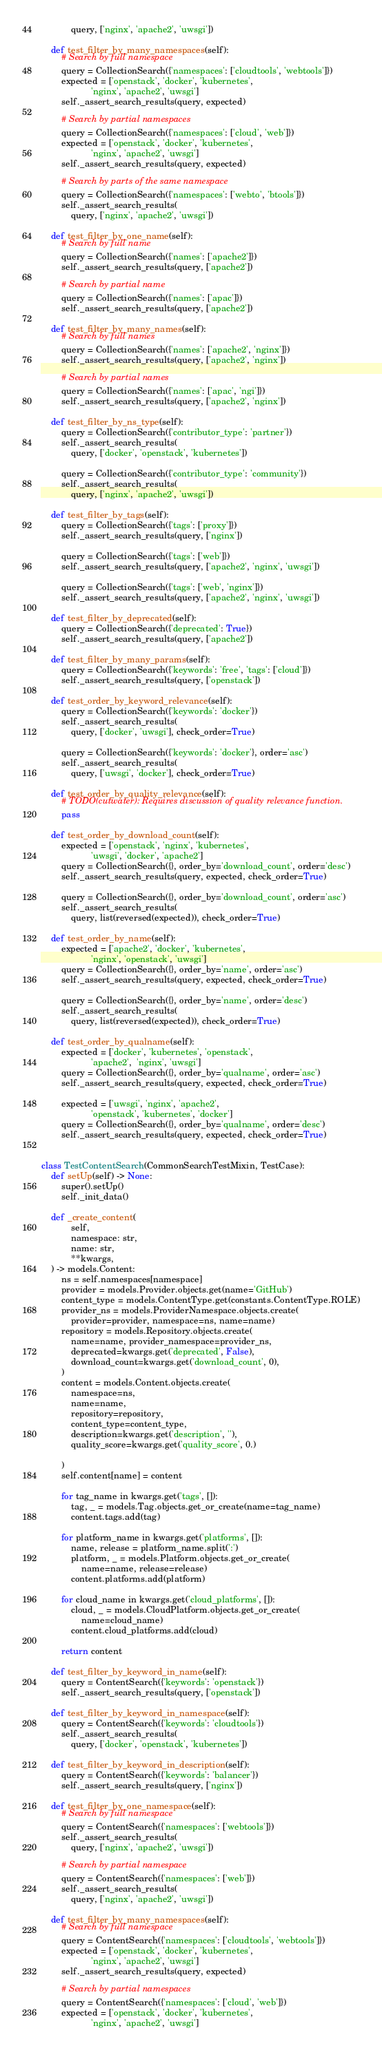Convert code to text. <code><loc_0><loc_0><loc_500><loc_500><_Python_>            query, ['nginx', 'apache2', 'uwsgi'])

    def test_filter_by_many_namespaces(self):
        # Search by full namespace
        query = CollectionSearch({'namespaces': ['cloudtools', 'webtools']})
        expected = ['openstack', 'docker', 'kubernetes',
                    'nginx', 'apache2', 'uwsgi']
        self._assert_search_results(query, expected)

        # Search by partial namespaces
        query = CollectionSearch({'namespaces': ['cloud', 'web']})
        expected = ['openstack', 'docker', 'kubernetes',
                    'nginx', 'apache2', 'uwsgi']
        self._assert_search_results(query, expected)

        # Search by parts of the same namespace
        query = CollectionSearch({'namespaces': ['webto', 'btools']})
        self._assert_search_results(
            query, ['nginx', 'apache2', 'uwsgi'])

    def test_filter_by_one_name(self):
        # Search by full name
        query = CollectionSearch({'names': ['apache2']})
        self._assert_search_results(query, ['apache2'])

        # Search by partial name
        query = CollectionSearch({'names': ['apac']})
        self._assert_search_results(query, ['apache2'])

    def test_filter_by_many_names(self):
        # Search by full names
        query = CollectionSearch({'names': ['apache2', 'nginx']})
        self._assert_search_results(query, ['apache2', 'nginx'])

        # Search by partial names
        query = CollectionSearch({'names': ['apac', 'ngi']})
        self._assert_search_results(query, ['apache2', 'nginx'])

    def test_filter_by_ns_type(self):
        query = CollectionSearch({'contributor_type': 'partner'})
        self._assert_search_results(
            query, ['docker', 'openstack', 'kubernetes'])

        query = CollectionSearch({'contributor_type': 'community'})
        self._assert_search_results(
            query, ['nginx', 'apache2', 'uwsgi'])

    def test_filter_by_tags(self):
        query = CollectionSearch({'tags': ['proxy']})
        self._assert_search_results(query, ['nginx'])

        query = CollectionSearch({'tags': ['web']})
        self._assert_search_results(query, ['apache2', 'nginx', 'uwsgi'])

        query = CollectionSearch({'tags': ['web', 'nginx']})
        self._assert_search_results(query, ['apache2', 'nginx', 'uwsgi'])

    def test_filter_by_deprecated(self):
        query = CollectionSearch({'deprecated': True})
        self._assert_search_results(query, ['apache2'])

    def test_filter_by_many_params(self):
        query = CollectionSearch({'keywords': 'free', 'tags': ['cloud']})
        self._assert_search_results(query, ['openstack'])

    def test_order_by_keyword_relevance(self):
        query = CollectionSearch({'keywords': 'docker'})
        self._assert_search_results(
            query, ['docker', 'uwsgi'], check_order=True)

        query = CollectionSearch({'keywords': 'docker'}, order='asc')
        self._assert_search_results(
            query, ['uwsgi', 'docker'], check_order=True)

    def test_order_by_quality_relevance(self):
        # TODO(cutwater): Requires discussion of quality relevance function.
        pass

    def test_order_by_download_count(self):
        expected = ['openstack', 'nginx', 'kubernetes',
                    'uwsgi', 'docker', 'apache2']
        query = CollectionSearch({}, order_by='download_count', order='desc')
        self._assert_search_results(query, expected, check_order=True)

        query = CollectionSearch({}, order_by='download_count', order='asc')
        self._assert_search_results(
            query, list(reversed(expected)), check_order=True)

    def test_order_by_name(self):
        expected = ['apache2', 'docker', 'kubernetes',
                    'nginx', 'openstack', 'uwsgi']
        query = CollectionSearch({}, order_by='name', order='asc')
        self._assert_search_results(query, expected, check_order=True)

        query = CollectionSearch({}, order_by='name', order='desc')
        self._assert_search_results(
            query, list(reversed(expected)), check_order=True)

    def test_order_by_qualname(self):
        expected = ['docker', 'kubernetes', 'openstack',
                    'apache2',  'nginx', 'uwsgi']
        query = CollectionSearch({}, order_by='qualname', order='asc')
        self._assert_search_results(query, expected, check_order=True)

        expected = ['uwsgi', 'nginx', 'apache2',
                    'openstack', 'kubernetes', 'docker']
        query = CollectionSearch({}, order_by='qualname', order='desc')
        self._assert_search_results(query, expected, check_order=True)


class TestContentSearch(CommonSearchTestMixin, TestCase):
    def setUp(self) -> None:
        super().setUp()
        self._init_data()

    def _create_content(
            self,
            namespace: str,
            name: str,
            **kwargs,
    ) -> models.Content:
        ns = self.namespaces[namespace]
        provider = models.Provider.objects.get(name='GitHub')
        content_type = models.ContentType.get(constants.ContentType.ROLE)
        provider_ns = models.ProviderNamespace.objects.create(
            provider=provider, namespace=ns, name=name)
        repository = models.Repository.objects.create(
            name=name, provider_namespace=provider_ns,
            deprecated=kwargs.get('deprecated', False),
            download_count=kwargs.get('download_count', 0),
        )
        content = models.Content.objects.create(
            namespace=ns,
            name=name,
            repository=repository,
            content_type=content_type,
            description=kwargs.get('description', ''),
            quality_score=kwargs.get('quality_score', 0.)

        )
        self.content[name] = content

        for tag_name in kwargs.get('tags', []):
            tag, _ = models.Tag.objects.get_or_create(name=tag_name)
            content.tags.add(tag)

        for platform_name in kwargs.get('platforms', []):
            name, release = platform_name.split(':')
            platform, _ = models.Platform.objects.get_or_create(
                name=name, release=release)
            content.platforms.add(platform)

        for cloud_name in kwargs.get('cloud_platforms', []):
            cloud, _ = models.CloudPlatform.objects.get_or_create(
                name=cloud_name)
            content.cloud_platforms.add(cloud)

        return content

    def test_filter_by_keyword_in_name(self):
        query = ContentSearch({'keywords': 'openstack'})
        self._assert_search_results(query, ['openstack'])

    def test_filter_by_keyword_in_namespace(self):
        query = ContentSearch({'keywords': 'cloudtools'})
        self._assert_search_results(
            query, ['docker', 'openstack', 'kubernetes'])

    def test_filter_by_keyword_in_description(self):
        query = ContentSearch({'keywords': 'balancer'})
        self._assert_search_results(query, ['nginx'])

    def test_filter_by_one_namespace(self):
        # Search by full namespace
        query = ContentSearch({'namespaces': ['webtools']})
        self._assert_search_results(
            query, ['nginx', 'apache2', 'uwsgi'])

        # Search by partial namespace
        query = ContentSearch({'namespaces': ['web']})
        self._assert_search_results(
            query, ['nginx', 'apache2', 'uwsgi'])

    def test_filter_by_many_namespaces(self):
        # Search by full namespace
        query = ContentSearch({'namespaces': ['cloudtools', 'webtools']})
        expected = ['openstack', 'docker', 'kubernetes',
                    'nginx', 'apache2', 'uwsgi']
        self._assert_search_results(query, expected)

        # Search by partial namespaces
        query = ContentSearch({'namespaces': ['cloud', 'web']})
        expected = ['openstack', 'docker', 'kubernetes',
                    'nginx', 'apache2', 'uwsgi']</code> 